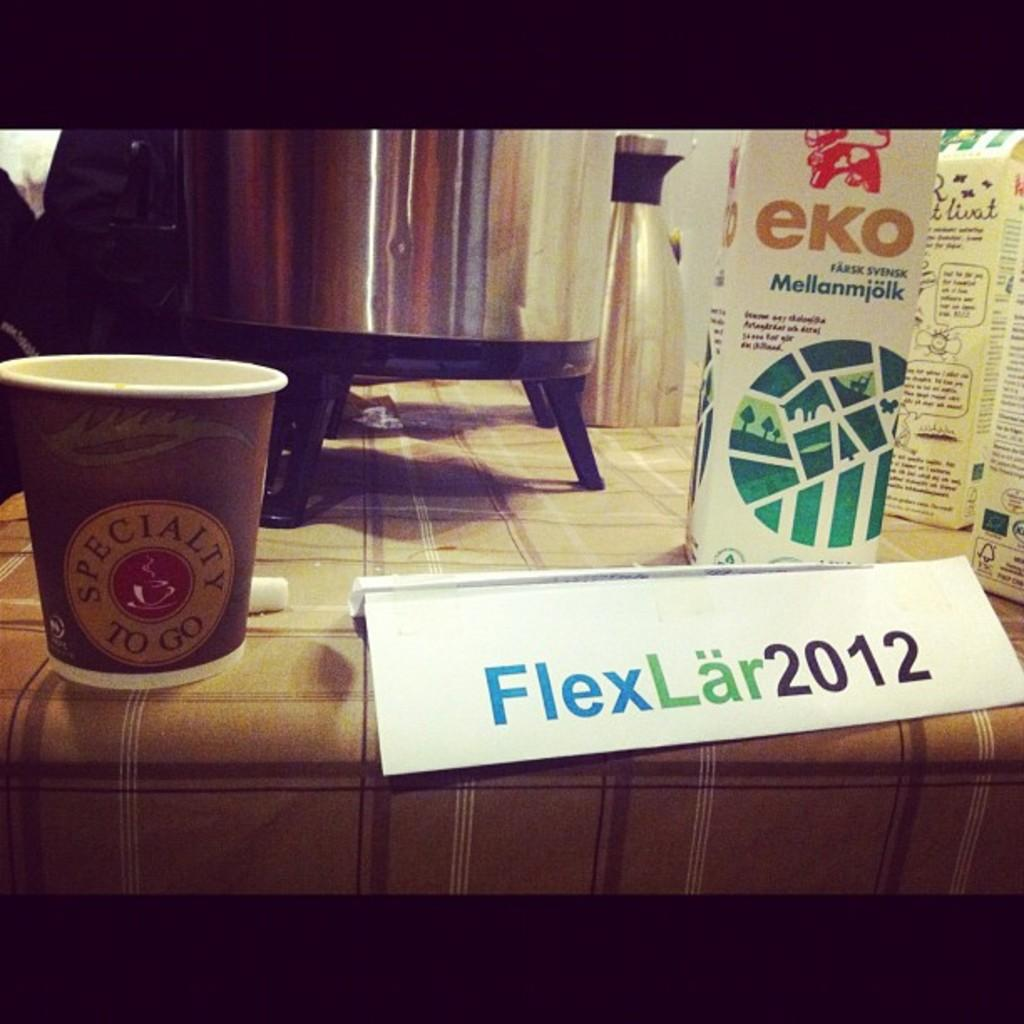What objects can be seen on the table in the image? There are bottles, carton boxes, and a small wooden holder on the table. Is there any identification or labeling on the table? Yes, there is a name plate on the table. What can be seen in the background of the image? There are clothes near a window, and there is a wall beside the clothes and window. What type of pump is visible in the image? There is no pump present in the image. Can you describe the color and texture of the sand in the image? There is no sand present in the image. 